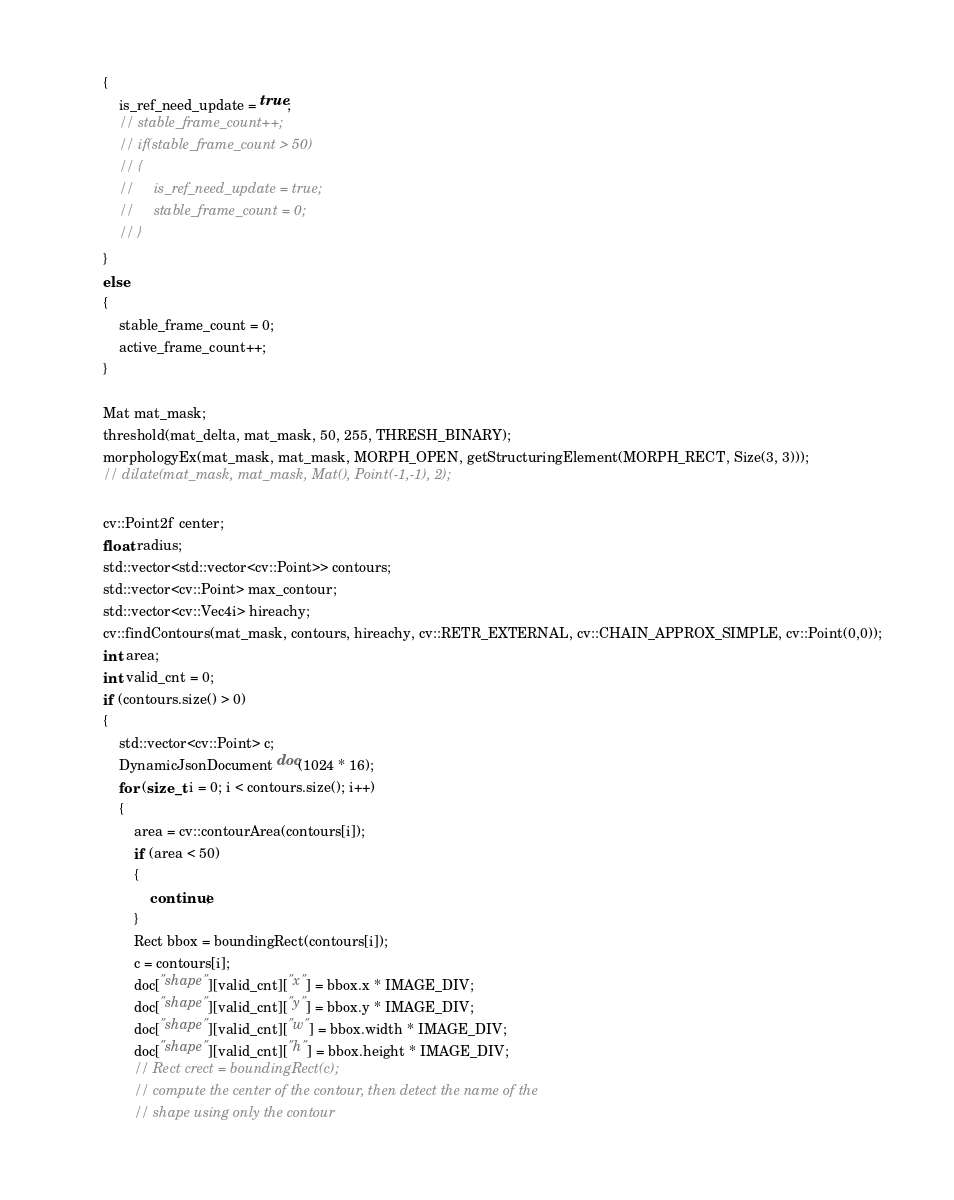Convert code to text. <code><loc_0><loc_0><loc_500><loc_500><_C++_>        {
            is_ref_need_update = true;
            // stable_frame_count++;
            // if(stable_frame_count > 50)
            // {
            //     is_ref_need_update = true;
            //     stable_frame_count = 0;
            // }
        }
        else
        {
            stable_frame_count = 0;
            active_frame_count++;
        }

        Mat mat_mask;
        threshold(mat_delta, mat_mask, 50, 255, THRESH_BINARY);
        morphologyEx(mat_mask, mat_mask, MORPH_OPEN, getStructuringElement(MORPH_RECT, Size(3, 3)));
        // dilate(mat_mask, mat_mask, Mat(), Point(-1,-1), 2);

        cv::Point2f center;
        float radius;
        std::vector<std::vector<cv::Point>> contours;
        std::vector<cv::Point> max_contour;
        std::vector<cv::Vec4i> hireachy;
        cv::findContours(mat_mask, contours, hireachy, cv::RETR_EXTERNAL, cv::CHAIN_APPROX_SIMPLE, cv::Point(0,0));
        int area;
        int valid_cnt = 0;
        if (contours.size() > 0)
        {
            std::vector<cv::Point> c;
            DynamicJsonDocument doc(1024 * 16);
            for (size_t i = 0; i < contours.size(); i++)
            {
                area = cv::contourArea(contours[i]);
                if (area < 50)
                {
                    continue;
                }
                Rect bbox = boundingRect(contours[i]);
                c = contours[i];
                doc["shape"][valid_cnt]["x"] = bbox.x * IMAGE_DIV;
                doc["shape"][valid_cnt]["y"] = bbox.y * IMAGE_DIV;
                doc["shape"][valid_cnt]["w"] = bbox.width * IMAGE_DIV;
                doc["shape"][valid_cnt]["h"] = bbox.height * IMAGE_DIV;
                // Rect crect = boundingRect(c);
                // compute the center of the contour, then detect the name of the
                // shape using only the contour</code> 